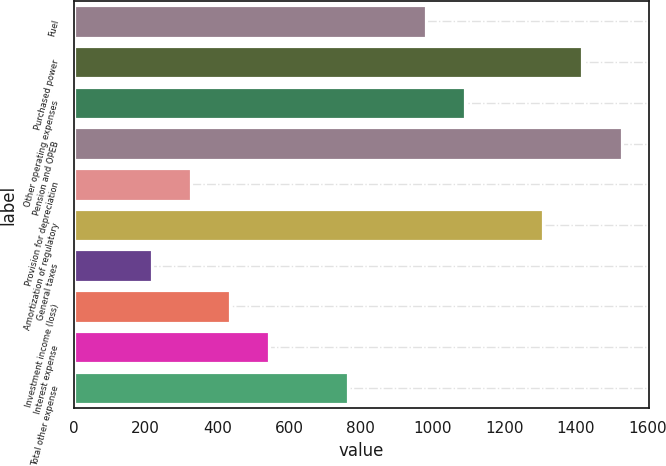Convert chart to OTSL. <chart><loc_0><loc_0><loc_500><loc_500><bar_chart><fcel>Fuel<fcel>Purchased power<fcel>Other operating expenses<fcel>Pension and OPEB<fcel>Provision for depreciation<fcel>Amortization of regulatory<fcel>General taxes<fcel>Investment income (loss)<fcel>Interest expense<fcel>Total other expense<nl><fcel>981.93<fcel>1418.17<fcel>1090.99<fcel>1527.23<fcel>327.57<fcel>1309.11<fcel>218.51<fcel>436.63<fcel>545.69<fcel>763.81<nl></chart> 